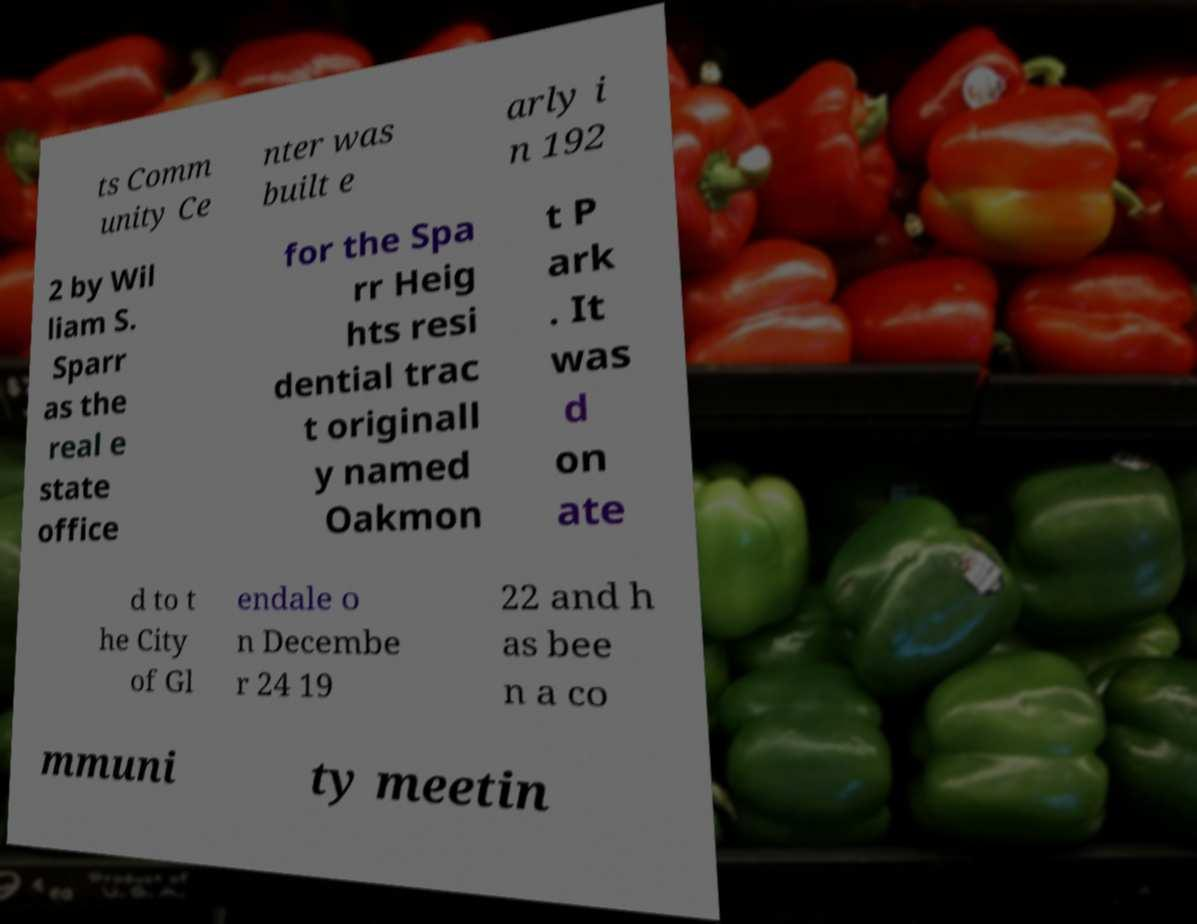Please identify and transcribe the text found in this image. ts Comm unity Ce nter was built e arly i n 192 2 by Wil liam S. Sparr as the real e state office for the Spa rr Heig hts resi dential trac t originall y named Oakmon t P ark . It was d on ate d to t he City of Gl endale o n Decembe r 24 19 22 and h as bee n a co mmuni ty meetin 